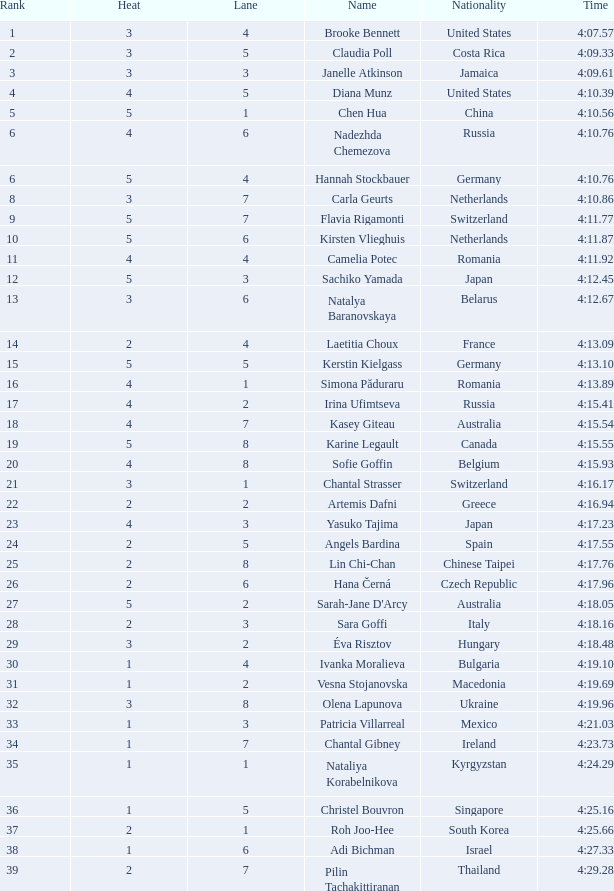What is the average rank when it is over 3 and the heat surpasses 5? None. 